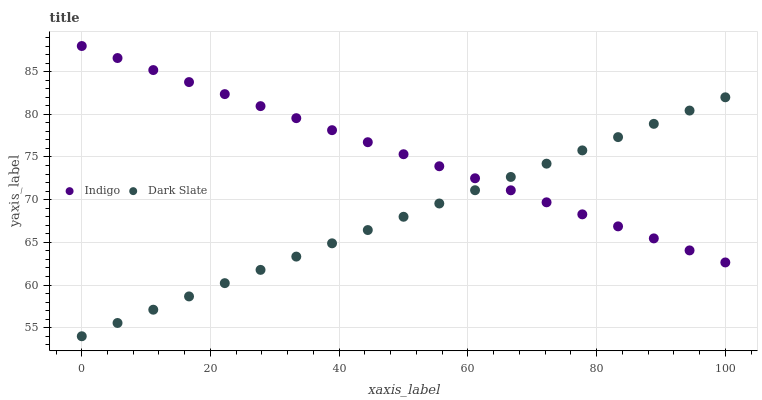Does Dark Slate have the minimum area under the curve?
Answer yes or no. Yes. Does Indigo have the maximum area under the curve?
Answer yes or no. Yes. Does Indigo have the minimum area under the curve?
Answer yes or no. No. Is Dark Slate the smoothest?
Answer yes or no. Yes. Is Indigo the roughest?
Answer yes or no. Yes. Is Indigo the smoothest?
Answer yes or no. No. Does Dark Slate have the lowest value?
Answer yes or no. Yes. Does Indigo have the lowest value?
Answer yes or no. No. Does Indigo have the highest value?
Answer yes or no. Yes. Does Dark Slate intersect Indigo?
Answer yes or no. Yes. Is Dark Slate less than Indigo?
Answer yes or no. No. Is Dark Slate greater than Indigo?
Answer yes or no. No. 